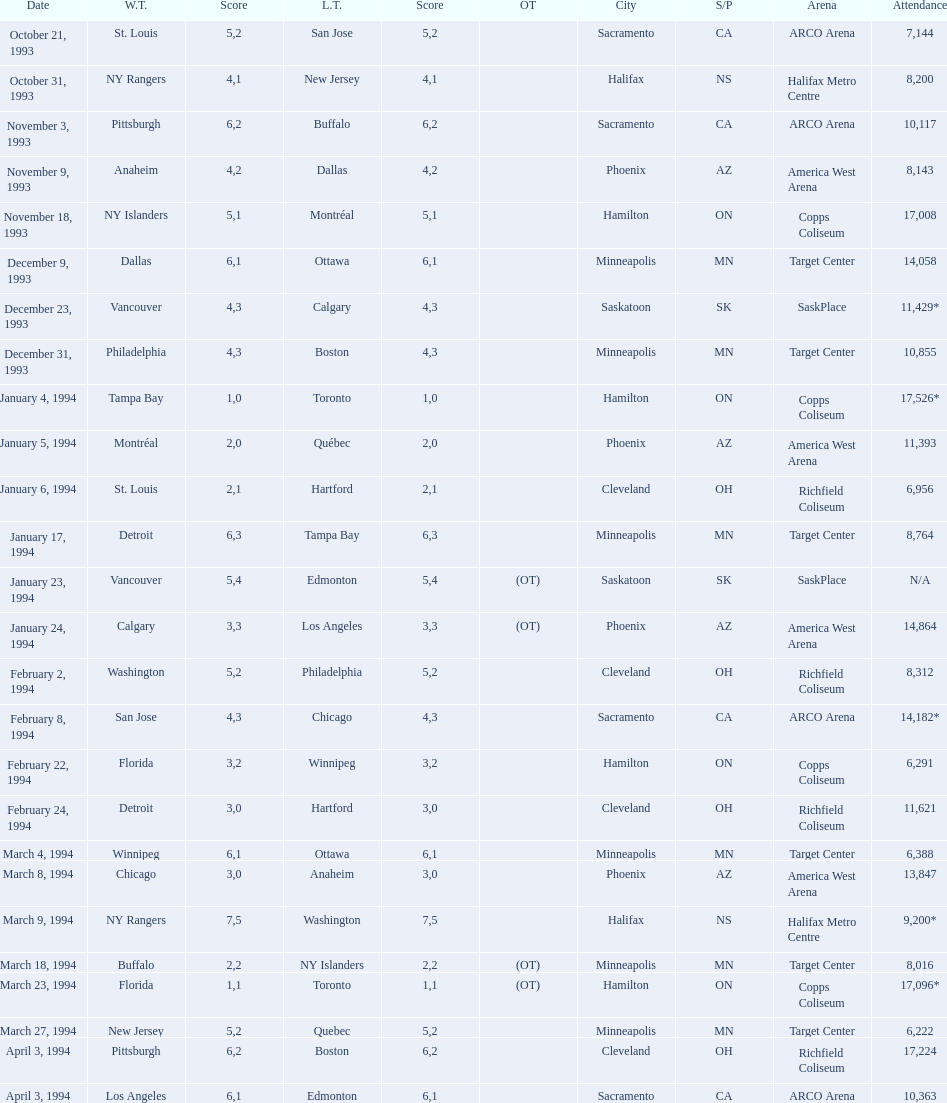Who triumphed in the contest a day before the january 5, 1994 game? Tampa Bay. 